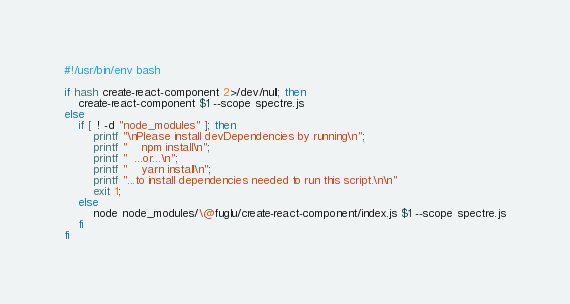<code> <loc_0><loc_0><loc_500><loc_500><_Bash_>#!/usr/bin/env bash

if hash create-react-component 2>/dev/null; then 
	create-react-component $1 --scope spectre.js
else 
	if [ ! -d "node_modules" ]; then
		printf "\nPlease install devDependencies by running\n";
		printf "    npm install\n";
		printf "  ...or...\n";
		printf "    yarn install\n";
		printf "...to install dependencies needed to run this script.\n\n"
		exit 1;
	else
		node node_modules/\@fuglu/create-react-component/index.js $1 --scope spectre.js
	fi
fi
</code> 